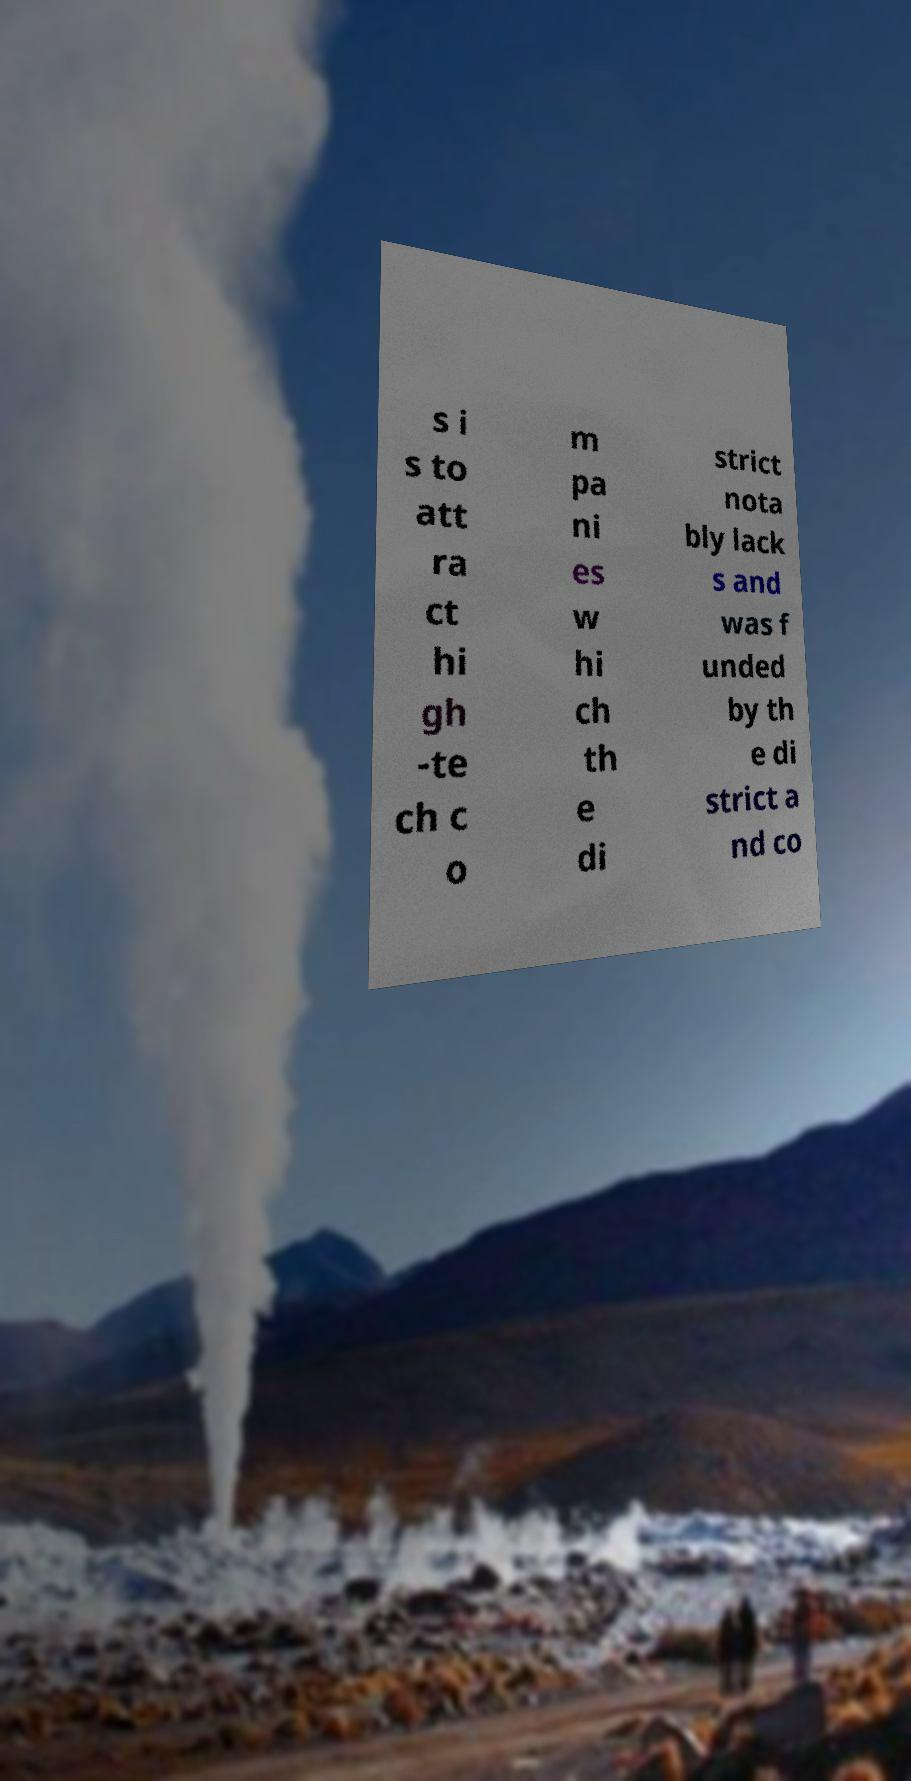For documentation purposes, I need the text within this image transcribed. Could you provide that? s i s to att ra ct hi gh -te ch c o m pa ni es w hi ch th e di strict nota bly lack s and was f unded by th e di strict a nd co 